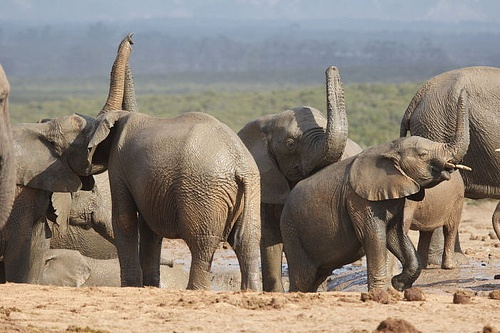Describe the objects in this image and their specific colors. I can see elephant in darkgray, black, and tan tones, elephant in darkgray, black, and gray tones, elephant in darkgray, black, and tan tones, elephant in darkgray, black, and gray tones, and elephant in darkgray, tan, black, and gray tones in this image. 